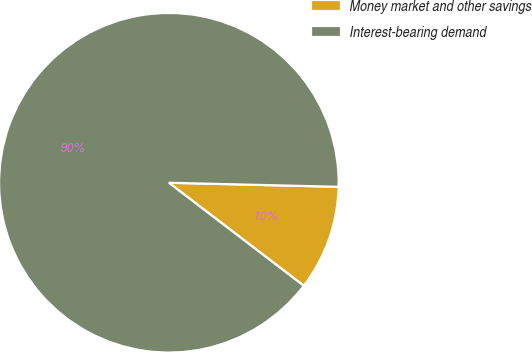<chart> <loc_0><loc_0><loc_500><loc_500><pie_chart><fcel>Money market and other savings<fcel>Interest-bearing demand<nl><fcel>10.0%<fcel>90.0%<nl></chart> 